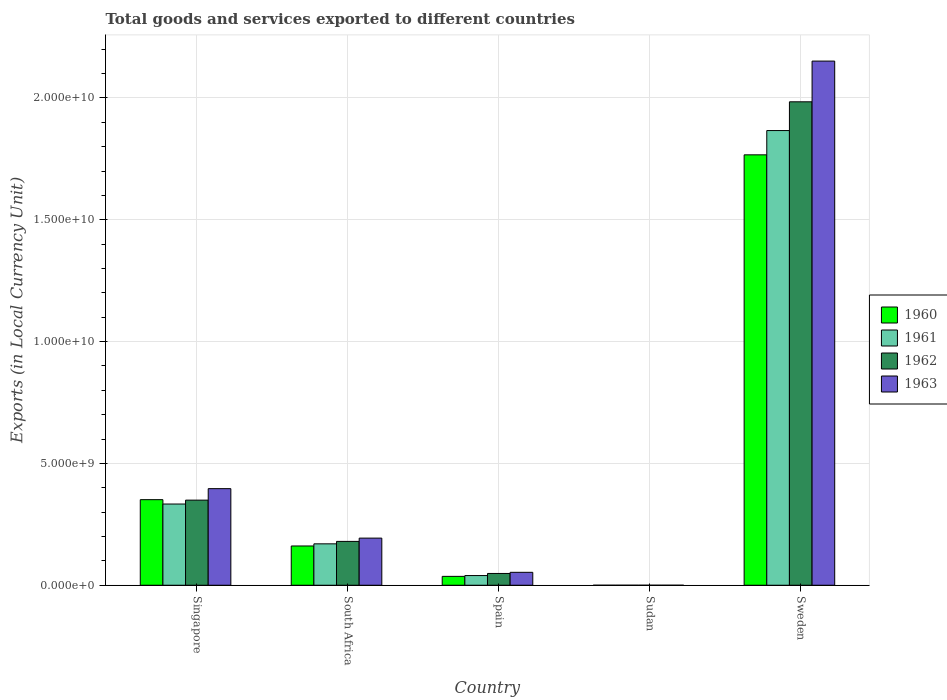How many different coloured bars are there?
Offer a terse response. 4. Are the number of bars per tick equal to the number of legend labels?
Your answer should be very brief. Yes. How many bars are there on the 5th tick from the right?
Provide a succinct answer. 4. What is the label of the 1st group of bars from the left?
Your answer should be very brief. Singapore. What is the Amount of goods and services exports in 1960 in South Africa?
Your answer should be compact. 1.61e+09. Across all countries, what is the maximum Amount of goods and services exports in 1963?
Provide a short and direct response. 2.15e+1. Across all countries, what is the minimum Amount of goods and services exports in 1963?
Provide a succinct answer. 7.86e+04. In which country was the Amount of goods and services exports in 1963 minimum?
Offer a terse response. Sudan. What is the total Amount of goods and services exports in 1960 in the graph?
Keep it short and to the point. 2.32e+1. What is the difference between the Amount of goods and services exports in 1960 in Singapore and that in South Africa?
Keep it short and to the point. 1.90e+09. What is the difference between the Amount of goods and services exports in 1960 in Sudan and the Amount of goods and services exports in 1963 in Spain?
Keep it short and to the point. -5.30e+08. What is the average Amount of goods and services exports in 1962 per country?
Your answer should be compact. 5.12e+09. What is the difference between the Amount of goods and services exports of/in 1960 and Amount of goods and services exports of/in 1963 in Spain?
Give a very brief answer. -1.66e+08. What is the ratio of the Amount of goods and services exports in 1960 in Singapore to that in South Africa?
Make the answer very short. 2.18. Is the Amount of goods and services exports in 1961 in Spain less than that in Sweden?
Ensure brevity in your answer.  Yes. Is the difference between the Amount of goods and services exports in 1960 in Singapore and South Africa greater than the difference between the Amount of goods and services exports in 1963 in Singapore and South Africa?
Provide a short and direct response. No. What is the difference between the highest and the second highest Amount of goods and services exports in 1961?
Keep it short and to the point. 1.70e+1. What is the difference between the highest and the lowest Amount of goods and services exports in 1963?
Provide a short and direct response. 2.15e+1. What does the 3rd bar from the right in Sweden represents?
Offer a very short reply. 1961. Is it the case that in every country, the sum of the Amount of goods and services exports in 1960 and Amount of goods and services exports in 1962 is greater than the Amount of goods and services exports in 1961?
Offer a very short reply. Yes. How many bars are there?
Provide a short and direct response. 20. Are all the bars in the graph horizontal?
Ensure brevity in your answer.  No. How many countries are there in the graph?
Keep it short and to the point. 5. Are the values on the major ticks of Y-axis written in scientific E-notation?
Offer a very short reply. Yes. Does the graph contain any zero values?
Ensure brevity in your answer.  No. How many legend labels are there?
Provide a succinct answer. 4. What is the title of the graph?
Provide a short and direct response. Total goods and services exported to different countries. What is the label or title of the Y-axis?
Keep it short and to the point. Exports (in Local Currency Unit). What is the Exports (in Local Currency Unit) of 1960 in Singapore?
Make the answer very short. 3.51e+09. What is the Exports (in Local Currency Unit) in 1961 in Singapore?
Your answer should be compact. 3.33e+09. What is the Exports (in Local Currency Unit) in 1962 in Singapore?
Offer a very short reply. 3.49e+09. What is the Exports (in Local Currency Unit) in 1963 in Singapore?
Make the answer very short. 3.96e+09. What is the Exports (in Local Currency Unit) in 1960 in South Africa?
Your answer should be compact. 1.61e+09. What is the Exports (in Local Currency Unit) in 1961 in South Africa?
Your response must be concise. 1.70e+09. What is the Exports (in Local Currency Unit) of 1962 in South Africa?
Provide a short and direct response. 1.80e+09. What is the Exports (in Local Currency Unit) of 1963 in South Africa?
Give a very brief answer. 1.93e+09. What is the Exports (in Local Currency Unit) in 1960 in Spain?
Keep it short and to the point. 3.64e+08. What is the Exports (in Local Currency Unit) in 1961 in Spain?
Provide a short and direct response. 3.98e+08. What is the Exports (in Local Currency Unit) of 1962 in Spain?
Make the answer very short. 4.83e+08. What is the Exports (in Local Currency Unit) of 1963 in Spain?
Give a very brief answer. 5.30e+08. What is the Exports (in Local Currency Unit) of 1960 in Sudan?
Offer a terse response. 5.71e+04. What is the Exports (in Local Currency Unit) of 1961 in Sudan?
Give a very brief answer. 5.67e+04. What is the Exports (in Local Currency Unit) in 1962 in Sudan?
Offer a very short reply. 6.76e+04. What is the Exports (in Local Currency Unit) of 1963 in Sudan?
Provide a short and direct response. 7.86e+04. What is the Exports (in Local Currency Unit) in 1960 in Sweden?
Provide a succinct answer. 1.77e+1. What is the Exports (in Local Currency Unit) in 1961 in Sweden?
Offer a very short reply. 1.87e+1. What is the Exports (in Local Currency Unit) of 1962 in Sweden?
Offer a terse response. 1.98e+1. What is the Exports (in Local Currency Unit) of 1963 in Sweden?
Provide a short and direct response. 2.15e+1. Across all countries, what is the maximum Exports (in Local Currency Unit) of 1960?
Offer a terse response. 1.77e+1. Across all countries, what is the maximum Exports (in Local Currency Unit) of 1961?
Your answer should be very brief. 1.87e+1. Across all countries, what is the maximum Exports (in Local Currency Unit) in 1962?
Make the answer very short. 1.98e+1. Across all countries, what is the maximum Exports (in Local Currency Unit) of 1963?
Give a very brief answer. 2.15e+1. Across all countries, what is the minimum Exports (in Local Currency Unit) of 1960?
Keep it short and to the point. 5.71e+04. Across all countries, what is the minimum Exports (in Local Currency Unit) in 1961?
Give a very brief answer. 5.67e+04. Across all countries, what is the minimum Exports (in Local Currency Unit) of 1962?
Make the answer very short. 6.76e+04. Across all countries, what is the minimum Exports (in Local Currency Unit) of 1963?
Your answer should be compact. 7.86e+04. What is the total Exports (in Local Currency Unit) of 1960 in the graph?
Offer a very short reply. 2.32e+1. What is the total Exports (in Local Currency Unit) in 1961 in the graph?
Your answer should be compact. 2.41e+1. What is the total Exports (in Local Currency Unit) of 1962 in the graph?
Your answer should be compact. 2.56e+1. What is the total Exports (in Local Currency Unit) in 1963 in the graph?
Provide a succinct answer. 2.79e+1. What is the difference between the Exports (in Local Currency Unit) in 1960 in Singapore and that in South Africa?
Your answer should be compact. 1.90e+09. What is the difference between the Exports (in Local Currency Unit) of 1961 in Singapore and that in South Africa?
Your answer should be very brief. 1.63e+09. What is the difference between the Exports (in Local Currency Unit) in 1962 in Singapore and that in South Africa?
Your response must be concise. 1.69e+09. What is the difference between the Exports (in Local Currency Unit) in 1963 in Singapore and that in South Africa?
Make the answer very short. 2.03e+09. What is the difference between the Exports (in Local Currency Unit) of 1960 in Singapore and that in Spain?
Your response must be concise. 3.15e+09. What is the difference between the Exports (in Local Currency Unit) in 1961 in Singapore and that in Spain?
Provide a succinct answer. 2.94e+09. What is the difference between the Exports (in Local Currency Unit) of 1962 in Singapore and that in Spain?
Give a very brief answer. 3.01e+09. What is the difference between the Exports (in Local Currency Unit) of 1963 in Singapore and that in Spain?
Make the answer very short. 3.43e+09. What is the difference between the Exports (in Local Currency Unit) in 1960 in Singapore and that in Sudan?
Your response must be concise. 3.51e+09. What is the difference between the Exports (in Local Currency Unit) in 1961 in Singapore and that in Sudan?
Your answer should be very brief. 3.33e+09. What is the difference between the Exports (in Local Currency Unit) in 1962 in Singapore and that in Sudan?
Ensure brevity in your answer.  3.49e+09. What is the difference between the Exports (in Local Currency Unit) of 1963 in Singapore and that in Sudan?
Make the answer very short. 3.96e+09. What is the difference between the Exports (in Local Currency Unit) in 1960 in Singapore and that in Sweden?
Your response must be concise. -1.42e+1. What is the difference between the Exports (in Local Currency Unit) of 1961 in Singapore and that in Sweden?
Your response must be concise. -1.53e+1. What is the difference between the Exports (in Local Currency Unit) in 1962 in Singapore and that in Sweden?
Your answer should be very brief. -1.64e+1. What is the difference between the Exports (in Local Currency Unit) in 1963 in Singapore and that in Sweden?
Your response must be concise. -1.76e+1. What is the difference between the Exports (in Local Currency Unit) of 1960 in South Africa and that in Spain?
Your answer should be compact. 1.25e+09. What is the difference between the Exports (in Local Currency Unit) in 1961 in South Africa and that in Spain?
Give a very brief answer. 1.30e+09. What is the difference between the Exports (in Local Currency Unit) in 1962 in South Africa and that in Spain?
Your answer should be very brief. 1.32e+09. What is the difference between the Exports (in Local Currency Unit) in 1963 in South Africa and that in Spain?
Provide a short and direct response. 1.40e+09. What is the difference between the Exports (in Local Currency Unit) of 1960 in South Africa and that in Sudan?
Offer a terse response. 1.61e+09. What is the difference between the Exports (in Local Currency Unit) of 1961 in South Africa and that in Sudan?
Give a very brief answer. 1.70e+09. What is the difference between the Exports (in Local Currency Unit) in 1962 in South Africa and that in Sudan?
Give a very brief answer. 1.80e+09. What is the difference between the Exports (in Local Currency Unit) in 1963 in South Africa and that in Sudan?
Keep it short and to the point. 1.93e+09. What is the difference between the Exports (in Local Currency Unit) of 1960 in South Africa and that in Sweden?
Give a very brief answer. -1.61e+1. What is the difference between the Exports (in Local Currency Unit) of 1961 in South Africa and that in Sweden?
Your answer should be very brief. -1.70e+1. What is the difference between the Exports (in Local Currency Unit) in 1962 in South Africa and that in Sweden?
Your answer should be very brief. -1.80e+1. What is the difference between the Exports (in Local Currency Unit) in 1963 in South Africa and that in Sweden?
Ensure brevity in your answer.  -1.96e+1. What is the difference between the Exports (in Local Currency Unit) in 1960 in Spain and that in Sudan?
Provide a short and direct response. 3.64e+08. What is the difference between the Exports (in Local Currency Unit) in 1961 in Spain and that in Sudan?
Make the answer very short. 3.98e+08. What is the difference between the Exports (in Local Currency Unit) in 1962 in Spain and that in Sudan?
Offer a terse response. 4.83e+08. What is the difference between the Exports (in Local Currency Unit) in 1963 in Spain and that in Sudan?
Keep it short and to the point. 5.30e+08. What is the difference between the Exports (in Local Currency Unit) of 1960 in Spain and that in Sweden?
Make the answer very short. -1.73e+1. What is the difference between the Exports (in Local Currency Unit) of 1961 in Spain and that in Sweden?
Your answer should be compact. -1.83e+1. What is the difference between the Exports (in Local Currency Unit) of 1962 in Spain and that in Sweden?
Provide a succinct answer. -1.94e+1. What is the difference between the Exports (in Local Currency Unit) of 1963 in Spain and that in Sweden?
Offer a very short reply. -2.10e+1. What is the difference between the Exports (in Local Currency Unit) of 1960 in Sudan and that in Sweden?
Provide a succinct answer. -1.77e+1. What is the difference between the Exports (in Local Currency Unit) of 1961 in Sudan and that in Sweden?
Provide a short and direct response. -1.87e+1. What is the difference between the Exports (in Local Currency Unit) in 1962 in Sudan and that in Sweden?
Your answer should be compact. -1.98e+1. What is the difference between the Exports (in Local Currency Unit) in 1963 in Sudan and that in Sweden?
Give a very brief answer. -2.15e+1. What is the difference between the Exports (in Local Currency Unit) of 1960 in Singapore and the Exports (in Local Currency Unit) of 1961 in South Africa?
Offer a terse response. 1.81e+09. What is the difference between the Exports (in Local Currency Unit) of 1960 in Singapore and the Exports (in Local Currency Unit) of 1962 in South Africa?
Provide a short and direct response. 1.71e+09. What is the difference between the Exports (in Local Currency Unit) of 1960 in Singapore and the Exports (in Local Currency Unit) of 1963 in South Africa?
Your answer should be very brief. 1.58e+09. What is the difference between the Exports (in Local Currency Unit) in 1961 in Singapore and the Exports (in Local Currency Unit) in 1962 in South Africa?
Your answer should be very brief. 1.53e+09. What is the difference between the Exports (in Local Currency Unit) of 1961 in Singapore and the Exports (in Local Currency Unit) of 1963 in South Africa?
Ensure brevity in your answer.  1.40e+09. What is the difference between the Exports (in Local Currency Unit) of 1962 in Singapore and the Exports (in Local Currency Unit) of 1963 in South Africa?
Give a very brief answer. 1.56e+09. What is the difference between the Exports (in Local Currency Unit) of 1960 in Singapore and the Exports (in Local Currency Unit) of 1961 in Spain?
Ensure brevity in your answer.  3.12e+09. What is the difference between the Exports (in Local Currency Unit) of 1960 in Singapore and the Exports (in Local Currency Unit) of 1962 in Spain?
Your answer should be compact. 3.03e+09. What is the difference between the Exports (in Local Currency Unit) in 1960 in Singapore and the Exports (in Local Currency Unit) in 1963 in Spain?
Keep it short and to the point. 2.98e+09. What is the difference between the Exports (in Local Currency Unit) in 1961 in Singapore and the Exports (in Local Currency Unit) in 1962 in Spain?
Provide a short and direct response. 2.85e+09. What is the difference between the Exports (in Local Currency Unit) of 1961 in Singapore and the Exports (in Local Currency Unit) of 1963 in Spain?
Provide a succinct answer. 2.80e+09. What is the difference between the Exports (in Local Currency Unit) of 1962 in Singapore and the Exports (in Local Currency Unit) of 1963 in Spain?
Your answer should be very brief. 2.96e+09. What is the difference between the Exports (in Local Currency Unit) in 1960 in Singapore and the Exports (in Local Currency Unit) in 1961 in Sudan?
Provide a succinct answer. 3.51e+09. What is the difference between the Exports (in Local Currency Unit) in 1960 in Singapore and the Exports (in Local Currency Unit) in 1962 in Sudan?
Ensure brevity in your answer.  3.51e+09. What is the difference between the Exports (in Local Currency Unit) of 1960 in Singapore and the Exports (in Local Currency Unit) of 1963 in Sudan?
Your response must be concise. 3.51e+09. What is the difference between the Exports (in Local Currency Unit) of 1961 in Singapore and the Exports (in Local Currency Unit) of 1962 in Sudan?
Keep it short and to the point. 3.33e+09. What is the difference between the Exports (in Local Currency Unit) of 1961 in Singapore and the Exports (in Local Currency Unit) of 1963 in Sudan?
Ensure brevity in your answer.  3.33e+09. What is the difference between the Exports (in Local Currency Unit) of 1962 in Singapore and the Exports (in Local Currency Unit) of 1963 in Sudan?
Your answer should be very brief. 3.49e+09. What is the difference between the Exports (in Local Currency Unit) in 1960 in Singapore and the Exports (in Local Currency Unit) in 1961 in Sweden?
Ensure brevity in your answer.  -1.52e+1. What is the difference between the Exports (in Local Currency Unit) of 1960 in Singapore and the Exports (in Local Currency Unit) of 1962 in Sweden?
Offer a very short reply. -1.63e+1. What is the difference between the Exports (in Local Currency Unit) in 1960 in Singapore and the Exports (in Local Currency Unit) in 1963 in Sweden?
Your answer should be compact. -1.80e+1. What is the difference between the Exports (in Local Currency Unit) in 1961 in Singapore and the Exports (in Local Currency Unit) in 1962 in Sweden?
Provide a short and direct response. -1.65e+1. What is the difference between the Exports (in Local Currency Unit) in 1961 in Singapore and the Exports (in Local Currency Unit) in 1963 in Sweden?
Provide a succinct answer. -1.82e+1. What is the difference between the Exports (in Local Currency Unit) of 1962 in Singapore and the Exports (in Local Currency Unit) of 1963 in Sweden?
Offer a very short reply. -1.80e+1. What is the difference between the Exports (in Local Currency Unit) of 1960 in South Africa and the Exports (in Local Currency Unit) of 1961 in Spain?
Give a very brief answer. 1.21e+09. What is the difference between the Exports (in Local Currency Unit) in 1960 in South Africa and the Exports (in Local Currency Unit) in 1962 in Spain?
Provide a short and direct response. 1.13e+09. What is the difference between the Exports (in Local Currency Unit) in 1960 in South Africa and the Exports (in Local Currency Unit) in 1963 in Spain?
Your response must be concise. 1.08e+09. What is the difference between the Exports (in Local Currency Unit) of 1961 in South Africa and the Exports (in Local Currency Unit) of 1962 in Spain?
Keep it short and to the point. 1.22e+09. What is the difference between the Exports (in Local Currency Unit) of 1961 in South Africa and the Exports (in Local Currency Unit) of 1963 in Spain?
Ensure brevity in your answer.  1.17e+09. What is the difference between the Exports (in Local Currency Unit) of 1962 in South Africa and the Exports (in Local Currency Unit) of 1963 in Spain?
Offer a terse response. 1.27e+09. What is the difference between the Exports (in Local Currency Unit) of 1960 in South Africa and the Exports (in Local Currency Unit) of 1961 in Sudan?
Provide a short and direct response. 1.61e+09. What is the difference between the Exports (in Local Currency Unit) of 1960 in South Africa and the Exports (in Local Currency Unit) of 1962 in Sudan?
Your response must be concise. 1.61e+09. What is the difference between the Exports (in Local Currency Unit) of 1960 in South Africa and the Exports (in Local Currency Unit) of 1963 in Sudan?
Offer a terse response. 1.61e+09. What is the difference between the Exports (in Local Currency Unit) of 1961 in South Africa and the Exports (in Local Currency Unit) of 1962 in Sudan?
Ensure brevity in your answer.  1.70e+09. What is the difference between the Exports (in Local Currency Unit) in 1961 in South Africa and the Exports (in Local Currency Unit) in 1963 in Sudan?
Ensure brevity in your answer.  1.70e+09. What is the difference between the Exports (in Local Currency Unit) of 1962 in South Africa and the Exports (in Local Currency Unit) of 1963 in Sudan?
Your response must be concise. 1.80e+09. What is the difference between the Exports (in Local Currency Unit) of 1960 in South Africa and the Exports (in Local Currency Unit) of 1961 in Sweden?
Make the answer very short. -1.71e+1. What is the difference between the Exports (in Local Currency Unit) in 1960 in South Africa and the Exports (in Local Currency Unit) in 1962 in Sweden?
Keep it short and to the point. -1.82e+1. What is the difference between the Exports (in Local Currency Unit) of 1960 in South Africa and the Exports (in Local Currency Unit) of 1963 in Sweden?
Provide a short and direct response. -1.99e+1. What is the difference between the Exports (in Local Currency Unit) of 1961 in South Africa and the Exports (in Local Currency Unit) of 1962 in Sweden?
Keep it short and to the point. -1.81e+1. What is the difference between the Exports (in Local Currency Unit) of 1961 in South Africa and the Exports (in Local Currency Unit) of 1963 in Sweden?
Your answer should be very brief. -1.98e+1. What is the difference between the Exports (in Local Currency Unit) in 1962 in South Africa and the Exports (in Local Currency Unit) in 1963 in Sweden?
Keep it short and to the point. -1.97e+1. What is the difference between the Exports (in Local Currency Unit) of 1960 in Spain and the Exports (in Local Currency Unit) of 1961 in Sudan?
Your response must be concise. 3.64e+08. What is the difference between the Exports (in Local Currency Unit) of 1960 in Spain and the Exports (in Local Currency Unit) of 1962 in Sudan?
Your response must be concise. 3.64e+08. What is the difference between the Exports (in Local Currency Unit) in 1960 in Spain and the Exports (in Local Currency Unit) in 1963 in Sudan?
Your response must be concise. 3.64e+08. What is the difference between the Exports (in Local Currency Unit) of 1961 in Spain and the Exports (in Local Currency Unit) of 1962 in Sudan?
Your response must be concise. 3.98e+08. What is the difference between the Exports (in Local Currency Unit) of 1961 in Spain and the Exports (in Local Currency Unit) of 1963 in Sudan?
Provide a succinct answer. 3.98e+08. What is the difference between the Exports (in Local Currency Unit) of 1962 in Spain and the Exports (in Local Currency Unit) of 1963 in Sudan?
Offer a terse response. 4.83e+08. What is the difference between the Exports (in Local Currency Unit) in 1960 in Spain and the Exports (in Local Currency Unit) in 1961 in Sweden?
Offer a terse response. -1.83e+1. What is the difference between the Exports (in Local Currency Unit) in 1960 in Spain and the Exports (in Local Currency Unit) in 1962 in Sweden?
Give a very brief answer. -1.95e+1. What is the difference between the Exports (in Local Currency Unit) in 1960 in Spain and the Exports (in Local Currency Unit) in 1963 in Sweden?
Your answer should be very brief. -2.12e+1. What is the difference between the Exports (in Local Currency Unit) in 1961 in Spain and the Exports (in Local Currency Unit) in 1962 in Sweden?
Your answer should be compact. -1.94e+1. What is the difference between the Exports (in Local Currency Unit) in 1961 in Spain and the Exports (in Local Currency Unit) in 1963 in Sweden?
Give a very brief answer. -2.11e+1. What is the difference between the Exports (in Local Currency Unit) of 1962 in Spain and the Exports (in Local Currency Unit) of 1963 in Sweden?
Your answer should be very brief. -2.10e+1. What is the difference between the Exports (in Local Currency Unit) in 1960 in Sudan and the Exports (in Local Currency Unit) in 1961 in Sweden?
Offer a terse response. -1.87e+1. What is the difference between the Exports (in Local Currency Unit) of 1960 in Sudan and the Exports (in Local Currency Unit) of 1962 in Sweden?
Give a very brief answer. -1.98e+1. What is the difference between the Exports (in Local Currency Unit) in 1960 in Sudan and the Exports (in Local Currency Unit) in 1963 in Sweden?
Keep it short and to the point. -2.15e+1. What is the difference between the Exports (in Local Currency Unit) of 1961 in Sudan and the Exports (in Local Currency Unit) of 1962 in Sweden?
Your response must be concise. -1.98e+1. What is the difference between the Exports (in Local Currency Unit) in 1961 in Sudan and the Exports (in Local Currency Unit) in 1963 in Sweden?
Ensure brevity in your answer.  -2.15e+1. What is the difference between the Exports (in Local Currency Unit) in 1962 in Sudan and the Exports (in Local Currency Unit) in 1963 in Sweden?
Make the answer very short. -2.15e+1. What is the average Exports (in Local Currency Unit) of 1960 per country?
Provide a succinct answer. 4.63e+09. What is the average Exports (in Local Currency Unit) in 1961 per country?
Your answer should be compact. 4.82e+09. What is the average Exports (in Local Currency Unit) in 1962 per country?
Ensure brevity in your answer.  5.12e+09. What is the average Exports (in Local Currency Unit) of 1963 per country?
Provide a succinct answer. 5.59e+09. What is the difference between the Exports (in Local Currency Unit) in 1960 and Exports (in Local Currency Unit) in 1961 in Singapore?
Your answer should be very brief. 1.79e+08. What is the difference between the Exports (in Local Currency Unit) in 1960 and Exports (in Local Currency Unit) in 1962 in Singapore?
Your answer should be compact. 1.93e+07. What is the difference between the Exports (in Local Currency Unit) of 1960 and Exports (in Local Currency Unit) of 1963 in Singapore?
Offer a very short reply. -4.52e+08. What is the difference between the Exports (in Local Currency Unit) in 1961 and Exports (in Local Currency Unit) in 1962 in Singapore?
Give a very brief answer. -1.60e+08. What is the difference between the Exports (in Local Currency Unit) of 1961 and Exports (in Local Currency Unit) of 1963 in Singapore?
Your response must be concise. -6.31e+08. What is the difference between the Exports (in Local Currency Unit) in 1962 and Exports (in Local Currency Unit) in 1963 in Singapore?
Make the answer very short. -4.72e+08. What is the difference between the Exports (in Local Currency Unit) of 1960 and Exports (in Local Currency Unit) of 1961 in South Africa?
Make the answer very short. -8.74e+07. What is the difference between the Exports (in Local Currency Unit) in 1960 and Exports (in Local Currency Unit) in 1962 in South Africa?
Provide a short and direct response. -1.88e+08. What is the difference between the Exports (in Local Currency Unit) in 1960 and Exports (in Local Currency Unit) in 1963 in South Africa?
Offer a terse response. -3.23e+08. What is the difference between the Exports (in Local Currency Unit) of 1961 and Exports (in Local Currency Unit) of 1962 in South Africa?
Give a very brief answer. -1.00e+08. What is the difference between the Exports (in Local Currency Unit) in 1961 and Exports (in Local Currency Unit) in 1963 in South Africa?
Give a very brief answer. -2.35e+08. What is the difference between the Exports (in Local Currency Unit) of 1962 and Exports (in Local Currency Unit) of 1963 in South Africa?
Offer a terse response. -1.35e+08. What is the difference between the Exports (in Local Currency Unit) in 1960 and Exports (in Local Currency Unit) in 1961 in Spain?
Your response must be concise. -3.35e+07. What is the difference between the Exports (in Local Currency Unit) of 1960 and Exports (in Local Currency Unit) of 1962 in Spain?
Make the answer very short. -1.19e+08. What is the difference between the Exports (in Local Currency Unit) of 1960 and Exports (in Local Currency Unit) of 1963 in Spain?
Provide a short and direct response. -1.66e+08. What is the difference between the Exports (in Local Currency Unit) of 1961 and Exports (in Local Currency Unit) of 1962 in Spain?
Your response must be concise. -8.55e+07. What is the difference between the Exports (in Local Currency Unit) of 1961 and Exports (in Local Currency Unit) of 1963 in Spain?
Keep it short and to the point. -1.33e+08. What is the difference between the Exports (in Local Currency Unit) in 1962 and Exports (in Local Currency Unit) in 1963 in Spain?
Ensure brevity in your answer.  -4.72e+07. What is the difference between the Exports (in Local Currency Unit) in 1960 and Exports (in Local Currency Unit) in 1961 in Sudan?
Provide a short and direct response. 400. What is the difference between the Exports (in Local Currency Unit) of 1960 and Exports (in Local Currency Unit) of 1962 in Sudan?
Keep it short and to the point. -1.05e+04. What is the difference between the Exports (in Local Currency Unit) in 1960 and Exports (in Local Currency Unit) in 1963 in Sudan?
Give a very brief answer. -2.15e+04. What is the difference between the Exports (in Local Currency Unit) in 1961 and Exports (in Local Currency Unit) in 1962 in Sudan?
Make the answer very short. -1.09e+04. What is the difference between the Exports (in Local Currency Unit) of 1961 and Exports (in Local Currency Unit) of 1963 in Sudan?
Keep it short and to the point. -2.19e+04. What is the difference between the Exports (in Local Currency Unit) in 1962 and Exports (in Local Currency Unit) in 1963 in Sudan?
Your answer should be compact. -1.10e+04. What is the difference between the Exports (in Local Currency Unit) of 1960 and Exports (in Local Currency Unit) of 1961 in Sweden?
Provide a short and direct response. -9.97e+08. What is the difference between the Exports (in Local Currency Unit) in 1960 and Exports (in Local Currency Unit) in 1962 in Sweden?
Your answer should be compact. -2.18e+09. What is the difference between the Exports (in Local Currency Unit) in 1960 and Exports (in Local Currency Unit) in 1963 in Sweden?
Offer a very short reply. -3.85e+09. What is the difference between the Exports (in Local Currency Unit) of 1961 and Exports (in Local Currency Unit) of 1962 in Sweden?
Provide a short and direct response. -1.18e+09. What is the difference between the Exports (in Local Currency Unit) in 1961 and Exports (in Local Currency Unit) in 1963 in Sweden?
Give a very brief answer. -2.85e+09. What is the difference between the Exports (in Local Currency Unit) in 1962 and Exports (in Local Currency Unit) in 1963 in Sweden?
Your answer should be compact. -1.67e+09. What is the ratio of the Exports (in Local Currency Unit) in 1960 in Singapore to that in South Africa?
Provide a succinct answer. 2.18. What is the ratio of the Exports (in Local Currency Unit) of 1961 in Singapore to that in South Africa?
Give a very brief answer. 1.96. What is the ratio of the Exports (in Local Currency Unit) in 1962 in Singapore to that in South Africa?
Give a very brief answer. 1.94. What is the ratio of the Exports (in Local Currency Unit) in 1963 in Singapore to that in South Africa?
Give a very brief answer. 2.05. What is the ratio of the Exports (in Local Currency Unit) in 1960 in Singapore to that in Spain?
Offer a terse response. 9.64. What is the ratio of the Exports (in Local Currency Unit) in 1961 in Singapore to that in Spain?
Offer a very short reply. 8.38. What is the ratio of the Exports (in Local Currency Unit) in 1962 in Singapore to that in Spain?
Your response must be concise. 7.23. What is the ratio of the Exports (in Local Currency Unit) in 1963 in Singapore to that in Spain?
Your response must be concise. 7.47. What is the ratio of the Exports (in Local Currency Unit) in 1960 in Singapore to that in Sudan?
Your answer should be very brief. 6.15e+04. What is the ratio of the Exports (in Local Currency Unit) in 1961 in Singapore to that in Sudan?
Offer a very short reply. 5.88e+04. What is the ratio of the Exports (in Local Currency Unit) in 1962 in Singapore to that in Sudan?
Ensure brevity in your answer.  5.17e+04. What is the ratio of the Exports (in Local Currency Unit) of 1963 in Singapore to that in Sudan?
Your response must be concise. 5.04e+04. What is the ratio of the Exports (in Local Currency Unit) in 1960 in Singapore to that in Sweden?
Your answer should be very brief. 0.2. What is the ratio of the Exports (in Local Currency Unit) of 1961 in Singapore to that in Sweden?
Your answer should be very brief. 0.18. What is the ratio of the Exports (in Local Currency Unit) of 1962 in Singapore to that in Sweden?
Offer a very short reply. 0.18. What is the ratio of the Exports (in Local Currency Unit) of 1963 in Singapore to that in Sweden?
Provide a succinct answer. 0.18. What is the ratio of the Exports (in Local Currency Unit) in 1960 in South Africa to that in Spain?
Provide a succinct answer. 4.43. What is the ratio of the Exports (in Local Currency Unit) in 1961 in South Africa to that in Spain?
Your answer should be compact. 4.27. What is the ratio of the Exports (in Local Currency Unit) of 1962 in South Africa to that in Spain?
Keep it short and to the point. 3.72. What is the ratio of the Exports (in Local Currency Unit) in 1963 in South Africa to that in Spain?
Your answer should be compact. 3.65. What is the ratio of the Exports (in Local Currency Unit) of 1960 in South Africa to that in Sudan?
Your answer should be very brief. 2.82e+04. What is the ratio of the Exports (in Local Currency Unit) in 1961 in South Africa to that in Sudan?
Ensure brevity in your answer.  3.00e+04. What is the ratio of the Exports (in Local Currency Unit) of 1962 in South Africa to that in Sudan?
Offer a very short reply. 2.66e+04. What is the ratio of the Exports (in Local Currency Unit) of 1963 in South Africa to that in Sudan?
Make the answer very short. 2.46e+04. What is the ratio of the Exports (in Local Currency Unit) of 1960 in South Africa to that in Sweden?
Provide a short and direct response. 0.09. What is the ratio of the Exports (in Local Currency Unit) in 1961 in South Africa to that in Sweden?
Keep it short and to the point. 0.09. What is the ratio of the Exports (in Local Currency Unit) of 1962 in South Africa to that in Sweden?
Provide a succinct answer. 0.09. What is the ratio of the Exports (in Local Currency Unit) of 1963 in South Africa to that in Sweden?
Ensure brevity in your answer.  0.09. What is the ratio of the Exports (in Local Currency Unit) of 1960 in Spain to that in Sudan?
Your response must be concise. 6378.78. What is the ratio of the Exports (in Local Currency Unit) of 1961 in Spain to that in Sudan?
Make the answer very short. 7014.48. What is the ratio of the Exports (in Local Currency Unit) in 1962 in Spain to that in Sudan?
Give a very brief answer. 7148.61. What is the ratio of the Exports (in Local Currency Unit) in 1963 in Spain to that in Sudan?
Give a very brief answer. 6749.29. What is the ratio of the Exports (in Local Currency Unit) in 1960 in Spain to that in Sweden?
Your answer should be compact. 0.02. What is the ratio of the Exports (in Local Currency Unit) of 1961 in Spain to that in Sweden?
Offer a terse response. 0.02. What is the ratio of the Exports (in Local Currency Unit) of 1962 in Spain to that in Sweden?
Offer a very short reply. 0.02. What is the ratio of the Exports (in Local Currency Unit) in 1963 in Spain to that in Sweden?
Ensure brevity in your answer.  0.02. What is the ratio of the Exports (in Local Currency Unit) of 1960 in Sudan to that in Sweden?
Provide a succinct answer. 0. What is the ratio of the Exports (in Local Currency Unit) of 1961 in Sudan to that in Sweden?
Make the answer very short. 0. What is the difference between the highest and the second highest Exports (in Local Currency Unit) in 1960?
Make the answer very short. 1.42e+1. What is the difference between the highest and the second highest Exports (in Local Currency Unit) in 1961?
Offer a terse response. 1.53e+1. What is the difference between the highest and the second highest Exports (in Local Currency Unit) of 1962?
Ensure brevity in your answer.  1.64e+1. What is the difference between the highest and the second highest Exports (in Local Currency Unit) of 1963?
Keep it short and to the point. 1.76e+1. What is the difference between the highest and the lowest Exports (in Local Currency Unit) in 1960?
Your answer should be very brief. 1.77e+1. What is the difference between the highest and the lowest Exports (in Local Currency Unit) in 1961?
Your answer should be very brief. 1.87e+1. What is the difference between the highest and the lowest Exports (in Local Currency Unit) of 1962?
Offer a very short reply. 1.98e+1. What is the difference between the highest and the lowest Exports (in Local Currency Unit) of 1963?
Give a very brief answer. 2.15e+1. 